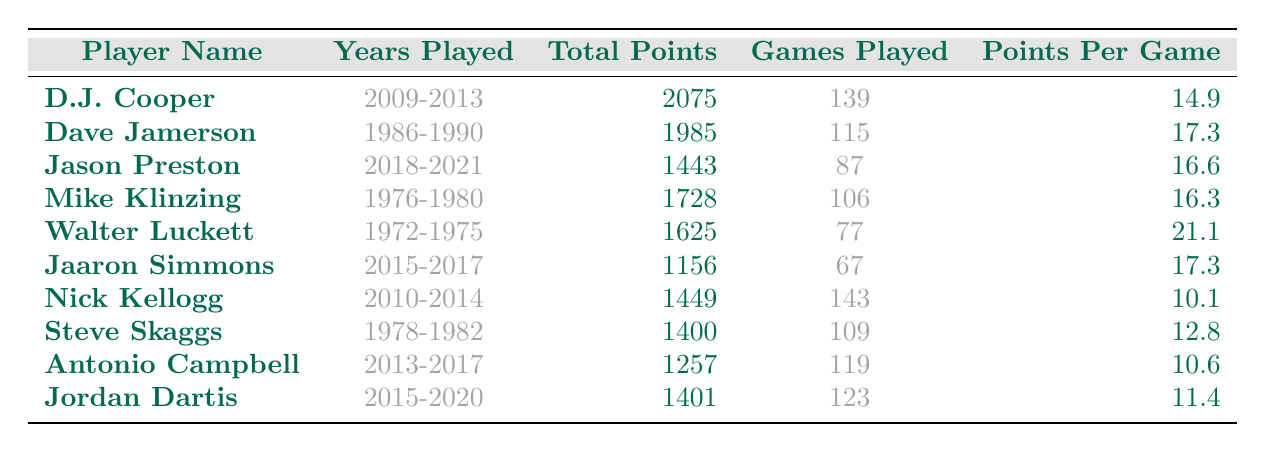What is the highest total points scored by an Ohio Bobcat guard? By reviewing the Total Points column, we see that D.J. Cooper scored 2075 points, which is the highest among all players listed.
Answer: 2075 Who has the highest Points Per Game average? Looking at the Points Per Game column, Walter Luckett has the highest average with 21.1 points per game.
Answer: 21.1 How many total points did Jason Preston score? The Total Points column indicates that Jason Preston scored 1443 points during his career.
Answer: 1443 Which guard played the most games? By examining the Games Played column, Nick Kellogg, with 143 games played, had the highest number of games.
Answer: 143 What is the average Points Per Game of the players listed? To find the average, sum up the points per game (14.9 + 17.3 + 16.6 + 16.3 + 21.1 + 17.3 + 10.1 + 12.8 + 10.6 + 11.4) =  10.4 and then divide by 10, which equals 14.51.
Answer: 14.51 Did any player score more than 1500 points? Yes, both D.J. Cooper and Mike Klinzing scored over 1500 points as shown in the Total Points column.
Answer: Yes What was the difference in total points between D.J. Cooper and Dave Jamerson? D.J. Cooper scored 2075 points, while Dave Jamerson scored 1985 points. The difference is 2075 - 1985 = 90 points.
Answer: 90 Which guard had the shortest career in terms of games played? Jaaron Simmons played 67 games, which is the fewest among the listed players according to the Games Played column.
Answer: 67 What is the total number of points scored by the guards who played in the 2010s? Summing the points: Nick Kellogg (1449) + D.J. Cooper (2075) + Jason Preston (1443) + Jaaron Simmons (1156) + Antonio Campbell (1257) + Jordan Dartis (1401), gives a total of 9,781 points.
Answer: 9781 Is the total points scored by Walter Luckett and Mike Klinzing greater than that of Jason Preston? Walter Luckett scored 1625 points and Mike Klinzing scored 1728 points, summing to 3353. Jason Preston scored 1443 points, so 3353 > 1443 is true.
Answer: Yes 